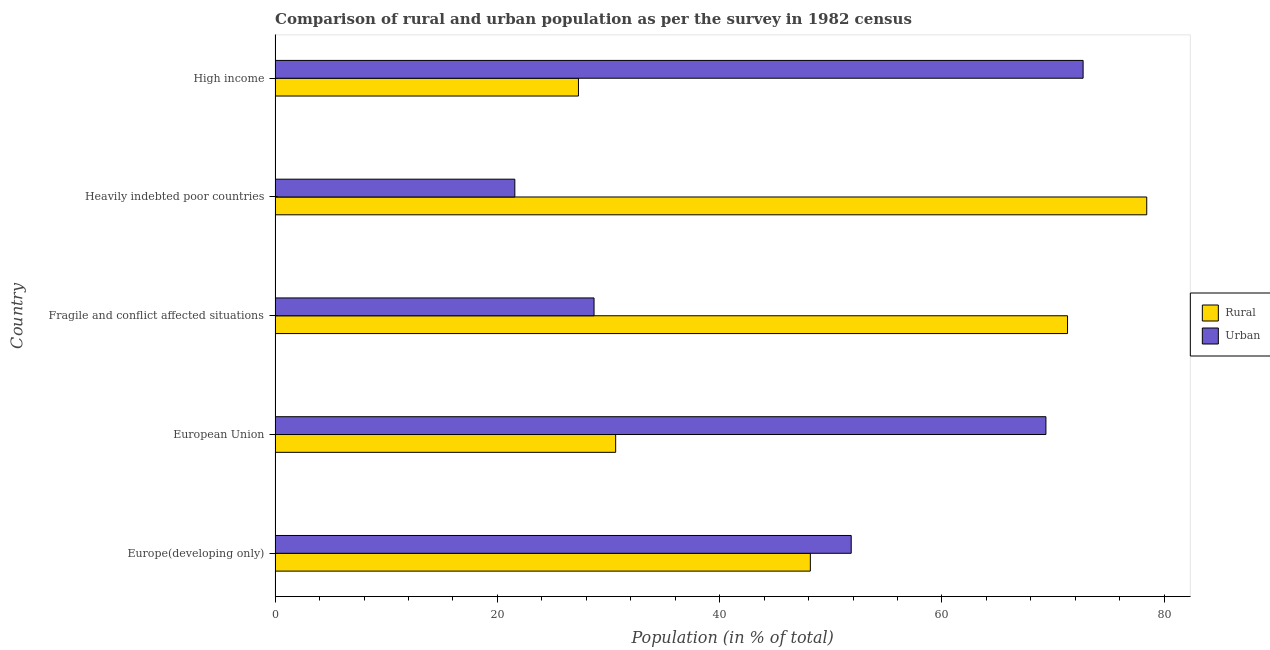How many different coloured bars are there?
Your response must be concise. 2. How many groups of bars are there?
Give a very brief answer. 5. In how many cases, is the number of bars for a given country not equal to the number of legend labels?
Provide a short and direct response. 0. What is the urban population in Heavily indebted poor countries?
Make the answer very short. 21.57. Across all countries, what is the maximum rural population?
Your response must be concise. 78.43. Across all countries, what is the minimum urban population?
Offer a terse response. 21.57. In which country was the urban population maximum?
Offer a terse response. High income. In which country was the rural population minimum?
Make the answer very short. High income. What is the total urban population in the graph?
Give a very brief answer. 244.17. What is the difference between the urban population in Europe(developing only) and that in European Union?
Provide a short and direct response. -17.52. What is the difference between the rural population in High income and the urban population in Fragile and conflict affected situations?
Your answer should be very brief. -1.4. What is the average rural population per country?
Give a very brief answer. 51.17. What is the difference between the urban population and rural population in Europe(developing only)?
Provide a short and direct response. 3.68. What is the ratio of the rural population in Heavily indebted poor countries to that in High income?
Provide a short and direct response. 2.87. What is the difference between the highest and the second highest urban population?
Give a very brief answer. 3.35. What is the difference between the highest and the lowest urban population?
Offer a terse response. 51.13. In how many countries, is the rural population greater than the average rural population taken over all countries?
Offer a terse response. 2. Is the sum of the urban population in Europe(developing only) and European Union greater than the maximum rural population across all countries?
Provide a succinct answer. Yes. What does the 1st bar from the top in Europe(developing only) represents?
Give a very brief answer. Urban. What does the 1st bar from the bottom in European Union represents?
Make the answer very short. Rural. How many countries are there in the graph?
Provide a short and direct response. 5. What is the difference between two consecutive major ticks on the X-axis?
Your response must be concise. 20. Are the values on the major ticks of X-axis written in scientific E-notation?
Make the answer very short. No. Does the graph contain any zero values?
Offer a terse response. No. Where does the legend appear in the graph?
Provide a short and direct response. Center right. What is the title of the graph?
Provide a succinct answer. Comparison of rural and urban population as per the survey in 1982 census. What is the label or title of the X-axis?
Your response must be concise. Population (in % of total). What is the label or title of the Y-axis?
Make the answer very short. Country. What is the Population (in % of total) in Rural in Europe(developing only)?
Provide a short and direct response. 48.16. What is the Population (in % of total) of Urban in Europe(developing only)?
Ensure brevity in your answer.  51.84. What is the Population (in % of total) in Rural in European Union?
Provide a succinct answer. 30.64. What is the Population (in % of total) of Urban in European Union?
Make the answer very short. 69.36. What is the Population (in % of total) of Rural in Fragile and conflict affected situations?
Offer a very short reply. 71.3. What is the Population (in % of total) in Urban in Fragile and conflict affected situations?
Offer a terse response. 28.7. What is the Population (in % of total) in Rural in Heavily indebted poor countries?
Your response must be concise. 78.43. What is the Population (in % of total) of Urban in Heavily indebted poor countries?
Offer a terse response. 21.57. What is the Population (in % of total) of Rural in High income?
Provide a succinct answer. 27.3. What is the Population (in % of total) of Urban in High income?
Provide a succinct answer. 72.7. Across all countries, what is the maximum Population (in % of total) of Rural?
Ensure brevity in your answer.  78.43. Across all countries, what is the maximum Population (in % of total) in Urban?
Ensure brevity in your answer.  72.7. Across all countries, what is the minimum Population (in % of total) of Rural?
Give a very brief answer. 27.3. Across all countries, what is the minimum Population (in % of total) of Urban?
Your answer should be very brief. 21.57. What is the total Population (in % of total) of Rural in the graph?
Provide a short and direct response. 255.83. What is the total Population (in % of total) of Urban in the graph?
Offer a very short reply. 244.17. What is the difference between the Population (in % of total) of Rural in Europe(developing only) and that in European Union?
Offer a terse response. 17.52. What is the difference between the Population (in % of total) in Urban in Europe(developing only) and that in European Union?
Your answer should be very brief. -17.52. What is the difference between the Population (in % of total) of Rural in Europe(developing only) and that in Fragile and conflict affected situations?
Offer a terse response. -23.14. What is the difference between the Population (in % of total) of Urban in Europe(developing only) and that in Fragile and conflict affected situations?
Your answer should be compact. 23.14. What is the difference between the Population (in % of total) of Rural in Europe(developing only) and that in Heavily indebted poor countries?
Your answer should be compact. -30.27. What is the difference between the Population (in % of total) in Urban in Europe(developing only) and that in Heavily indebted poor countries?
Your answer should be compact. 30.27. What is the difference between the Population (in % of total) of Rural in Europe(developing only) and that in High income?
Your answer should be very brief. 20.86. What is the difference between the Population (in % of total) of Urban in Europe(developing only) and that in High income?
Keep it short and to the point. -20.86. What is the difference between the Population (in % of total) of Rural in European Union and that in Fragile and conflict affected situations?
Provide a short and direct response. -40.66. What is the difference between the Population (in % of total) of Urban in European Union and that in Fragile and conflict affected situations?
Keep it short and to the point. 40.66. What is the difference between the Population (in % of total) in Rural in European Union and that in Heavily indebted poor countries?
Your response must be concise. -47.78. What is the difference between the Population (in % of total) in Urban in European Union and that in Heavily indebted poor countries?
Offer a very short reply. 47.78. What is the difference between the Population (in % of total) of Rural in European Union and that in High income?
Offer a very short reply. 3.35. What is the difference between the Population (in % of total) of Urban in European Union and that in High income?
Offer a very short reply. -3.35. What is the difference between the Population (in % of total) of Rural in Fragile and conflict affected situations and that in Heavily indebted poor countries?
Provide a succinct answer. -7.13. What is the difference between the Population (in % of total) of Urban in Fragile and conflict affected situations and that in Heavily indebted poor countries?
Ensure brevity in your answer.  7.13. What is the difference between the Population (in % of total) in Rural in Fragile and conflict affected situations and that in High income?
Offer a terse response. 44.01. What is the difference between the Population (in % of total) in Urban in Fragile and conflict affected situations and that in High income?
Offer a terse response. -44.01. What is the difference between the Population (in % of total) of Rural in Heavily indebted poor countries and that in High income?
Your answer should be very brief. 51.13. What is the difference between the Population (in % of total) of Urban in Heavily indebted poor countries and that in High income?
Your response must be concise. -51.13. What is the difference between the Population (in % of total) in Rural in Europe(developing only) and the Population (in % of total) in Urban in European Union?
Your answer should be compact. -21.2. What is the difference between the Population (in % of total) in Rural in Europe(developing only) and the Population (in % of total) in Urban in Fragile and conflict affected situations?
Make the answer very short. 19.46. What is the difference between the Population (in % of total) of Rural in Europe(developing only) and the Population (in % of total) of Urban in Heavily indebted poor countries?
Offer a very short reply. 26.59. What is the difference between the Population (in % of total) of Rural in Europe(developing only) and the Population (in % of total) of Urban in High income?
Your answer should be very brief. -24.54. What is the difference between the Population (in % of total) in Rural in European Union and the Population (in % of total) in Urban in Fragile and conflict affected situations?
Your response must be concise. 1.94. What is the difference between the Population (in % of total) in Rural in European Union and the Population (in % of total) in Urban in Heavily indebted poor countries?
Keep it short and to the point. 9.07. What is the difference between the Population (in % of total) of Rural in European Union and the Population (in % of total) of Urban in High income?
Keep it short and to the point. -42.06. What is the difference between the Population (in % of total) of Rural in Fragile and conflict affected situations and the Population (in % of total) of Urban in Heavily indebted poor countries?
Your answer should be very brief. 49.73. What is the difference between the Population (in % of total) of Rural in Fragile and conflict affected situations and the Population (in % of total) of Urban in High income?
Your answer should be very brief. -1.4. What is the difference between the Population (in % of total) in Rural in Heavily indebted poor countries and the Population (in % of total) in Urban in High income?
Offer a very short reply. 5.72. What is the average Population (in % of total) in Rural per country?
Provide a succinct answer. 51.17. What is the average Population (in % of total) of Urban per country?
Ensure brevity in your answer.  48.83. What is the difference between the Population (in % of total) of Rural and Population (in % of total) of Urban in Europe(developing only)?
Your answer should be compact. -3.68. What is the difference between the Population (in % of total) in Rural and Population (in % of total) in Urban in European Union?
Make the answer very short. -38.71. What is the difference between the Population (in % of total) of Rural and Population (in % of total) of Urban in Fragile and conflict affected situations?
Give a very brief answer. 42.6. What is the difference between the Population (in % of total) of Rural and Population (in % of total) of Urban in Heavily indebted poor countries?
Offer a terse response. 56.86. What is the difference between the Population (in % of total) of Rural and Population (in % of total) of Urban in High income?
Give a very brief answer. -45.41. What is the ratio of the Population (in % of total) in Rural in Europe(developing only) to that in European Union?
Your answer should be very brief. 1.57. What is the ratio of the Population (in % of total) of Urban in Europe(developing only) to that in European Union?
Give a very brief answer. 0.75. What is the ratio of the Population (in % of total) of Rural in Europe(developing only) to that in Fragile and conflict affected situations?
Provide a succinct answer. 0.68. What is the ratio of the Population (in % of total) in Urban in Europe(developing only) to that in Fragile and conflict affected situations?
Your answer should be compact. 1.81. What is the ratio of the Population (in % of total) of Rural in Europe(developing only) to that in Heavily indebted poor countries?
Make the answer very short. 0.61. What is the ratio of the Population (in % of total) of Urban in Europe(developing only) to that in Heavily indebted poor countries?
Ensure brevity in your answer.  2.4. What is the ratio of the Population (in % of total) of Rural in Europe(developing only) to that in High income?
Offer a terse response. 1.76. What is the ratio of the Population (in % of total) of Urban in Europe(developing only) to that in High income?
Provide a short and direct response. 0.71. What is the ratio of the Population (in % of total) in Rural in European Union to that in Fragile and conflict affected situations?
Give a very brief answer. 0.43. What is the ratio of the Population (in % of total) of Urban in European Union to that in Fragile and conflict affected situations?
Ensure brevity in your answer.  2.42. What is the ratio of the Population (in % of total) in Rural in European Union to that in Heavily indebted poor countries?
Offer a terse response. 0.39. What is the ratio of the Population (in % of total) of Urban in European Union to that in Heavily indebted poor countries?
Your answer should be compact. 3.22. What is the ratio of the Population (in % of total) in Rural in European Union to that in High income?
Offer a very short reply. 1.12. What is the ratio of the Population (in % of total) in Urban in European Union to that in High income?
Provide a short and direct response. 0.95. What is the ratio of the Population (in % of total) in Rural in Fragile and conflict affected situations to that in Heavily indebted poor countries?
Offer a very short reply. 0.91. What is the ratio of the Population (in % of total) of Urban in Fragile and conflict affected situations to that in Heavily indebted poor countries?
Give a very brief answer. 1.33. What is the ratio of the Population (in % of total) of Rural in Fragile and conflict affected situations to that in High income?
Ensure brevity in your answer.  2.61. What is the ratio of the Population (in % of total) in Urban in Fragile and conflict affected situations to that in High income?
Offer a very short reply. 0.39. What is the ratio of the Population (in % of total) in Rural in Heavily indebted poor countries to that in High income?
Your response must be concise. 2.87. What is the ratio of the Population (in % of total) of Urban in Heavily indebted poor countries to that in High income?
Give a very brief answer. 0.3. What is the difference between the highest and the second highest Population (in % of total) in Rural?
Give a very brief answer. 7.13. What is the difference between the highest and the second highest Population (in % of total) in Urban?
Make the answer very short. 3.35. What is the difference between the highest and the lowest Population (in % of total) in Rural?
Make the answer very short. 51.13. What is the difference between the highest and the lowest Population (in % of total) of Urban?
Offer a terse response. 51.13. 